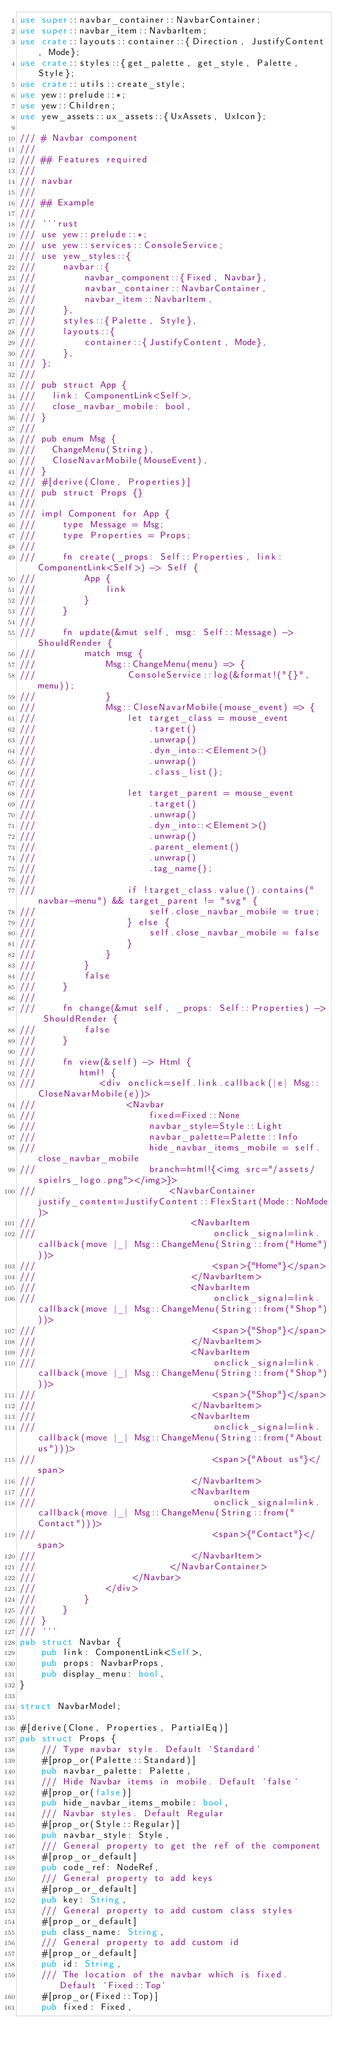Convert code to text. <code><loc_0><loc_0><loc_500><loc_500><_Rust_>use super::navbar_container::NavbarContainer;
use super::navbar_item::NavbarItem;
use crate::layouts::container::{Direction, JustifyContent, Mode};
use crate::styles::{get_palette, get_style, Palette, Style};
use crate::utils::create_style;
use yew::prelude::*;
use yew::Children;
use yew_assets::ux_assets::{UxAssets, UxIcon};

/// # Navbar component
///
/// ## Features required
///
/// navbar
///
/// ## Example
///
/// ```rust
/// use yew::prelude::*;
/// use yew::services::ConsoleService;
/// use yew_styles::{
///     navbar::{
///         navbar_component::{Fixed, Navbar},
///         navbar_container::NavbarContainer,
///         navbar_item::NavbarItem,
///     },
///     styles::{Palette, Style},
///     layouts::{
///         container::{JustifyContent, Mode},
///     },
/// };
///
/// pub struct App {
///   link: ComponentLink<Self>,
///   close_navbar_mobile: bool,
/// }
///
/// pub enum Msg {
///   ChangeMenu(String),
///   CloseNavarMobile(MouseEvent),
/// }
/// #[derive(Clone, Properties)]
/// pub struct Props {}
///
/// impl Component for App {
///     type Message = Msg;
///     type Properties = Props;
///
///     fn create(_props: Self::Properties, link: ComponentLink<Self>) -> Self {
///         App {
///             link
///         }
///     }
///
///     fn update(&mut self, msg: Self::Message) -> ShouldRender {
///         match msg {
///             Msg::ChangeMenu(menu) => {
///                 ConsoleService::log(&format!("{}", menu));
///             }
///             Msg::CloseNavarMobile(mouse_event) => {
///                 let target_class = mouse_event
///                     .target()
///                     .unwrap()
///                     .dyn_into::<Element>()
///                     .unwrap()
///                     .class_list();
///             
///                 let target_parent = mouse_event
///                     .target()
///                     .unwrap()
///                     .dyn_into::<Element>()
///                     .unwrap()
///                     .parent_element()
///                     .unwrap()
///                     .tag_name();
///                 
///                 if !target_class.value().contains("navbar-menu") && target_parent != "svg" {
///                     self.close_navbar_mobile = true;
///                 } else {
///                     self.close_navbar_mobile = false
///                 }
///             }
///         }
///         false
///     }
///
///     fn change(&mut self, _props: Self::Properties) -> ShouldRender {
///         false
///     }
///
///     fn view(&self) -> Html {
///        html! {
///            <div onclick=self.link.callback(|e| Msg::CloseNavarMobile(e))>
///                 <Navbar
///                     fixed=Fixed::None
///                     navbar_style=Style::Light
///                     navbar_palette=Palette::Info
///                     hide_navbar_items_mobile = self.close_navbar_mobile
///                     branch=html!{<img src="/assets/spielrs_logo.png"></img>}>
///                         <NavbarContainer justify_content=JustifyContent::FlexStart(Mode::NoMode)>
///                             <NavbarItem
///                                 onclick_signal=link.callback(move |_| Msg::ChangeMenu(String::from("Home")))>
///                                 <span>{"Home"}</span>
///                             </NavbarItem>
///                             <NavbarItem
///                                 onclick_signal=link.callback(move |_| Msg::ChangeMenu(String::from("Shop")))>
///                                 <span>{"Shop"}</span>
///                             </NavbarItem>
///                             <NavbarItem
///                                 onclick_signal=link.callback(move |_| Msg::ChangeMenu(String::from("Shop")))>
///                                 <span>{"Shop"}</span>
///                             </NavbarItem>
///                             <NavbarItem
///                                 onclick_signal=link.callback(move |_| Msg::ChangeMenu(String::from("About us")))>   
///                                 <span>{"About us"}</span>
///                             </NavbarItem>
///                             <NavbarItem
///                                 onclick_signal=link.callback(move |_| Msg::ChangeMenu(String::from("Contact")))>   
///                                 <span>{"Contact"}</span>
///                             </NavbarItem>
///                         </NavbarContainer>
///                  </Navbar>
///             </div>
///         }
///     }
/// }
/// ```
pub struct Navbar {
    pub link: ComponentLink<Self>,
    pub props: NavbarProps,
    pub display_menu: bool,
}

struct NavbarModel;

#[derive(Clone, Properties, PartialEq)]
pub struct Props {
    /// Type navbar style. Default `Standard`
    #[prop_or(Palette::Standard)]
    pub navbar_palette: Palette,
    /// Hide Navbar items in mobile. Default `false`
    #[prop_or(false)]
    pub hide_navbar_items_mobile: bool,
    /// Navbar styles. Default Regular
    #[prop_or(Style::Regular)]
    pub navbar_style: Style,
    /// General property to get the ref of the component
    #[prop_or_default]
    pub code_ref: NodeRef,
    /// General property to add keys
    #[prop_or_default]
    pub key: String,
    /// General property to add custom class styles
    #[prop_or_default]
    pub class_name: String,
    /// General property to add custom id
    #[prop_or_default]
    pub id: String,
    /// The location of the navbar which is fixed. Default `Fixed::Top`
    #[prop_or(Fixed::Top)]
    pub fixed: Fixed,</code> 